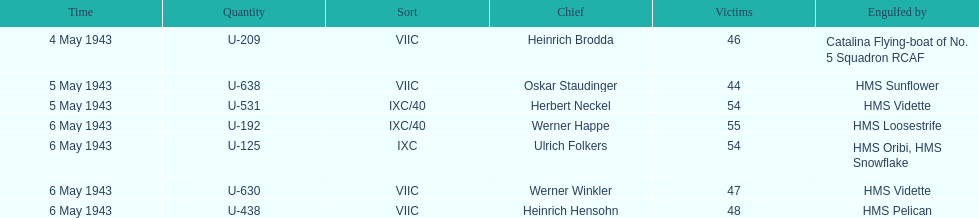What was the only captain sunk by hms pelican? Heinrich Hensohn. 